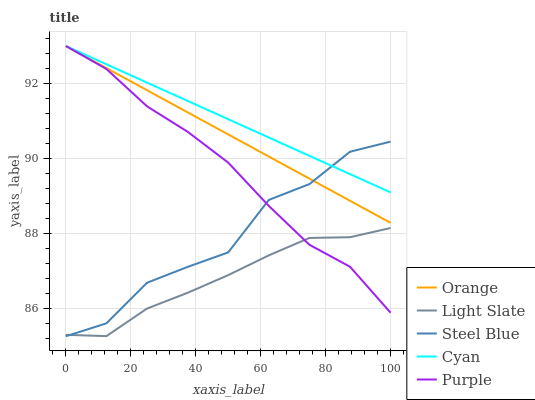Does Light Slate have the minimum area under the curve?
Answer yes or no. Yes. Does Cyan have the maximum area under the curve?
Answer yes or no. Yes. Does Steel Blue have the minimum area under the curve?
Answer yes or no. No. Does Steel Blue have the maximum area under the curve?
Answer yes or no. No. Is Orange the smoothest?
Answer yes or no. Yes. Is Steel Blue the roughest?
Answer yes or no. Yes. Is Light Slate the smoothest?
Answer yes or no. No. Is Light Slate the roughest?
Answer yes or no. No. Does Steel Blue have the lowest value?
Answer yes or no. Yes. Does Light Slate have the lowest value?
Answer yes or no. No. Does Cyan have the highest value?
Answer yes or no. Yes. Does Steel Blue have the highest value?
Answer yes or no. No. Is Light Slate less than Orange?
Answer yes or no. Yes. Is Orange greater than Light Slate?
Answer yes or no. Yes. Does Cyan intersect Orange?
Answer yes or no. Yes. Is Cyan less than Orange?
Answer yes or no. No. Is Cyan greater than Orange?
Answer yes or no. No. Does Light Slate intersect Orange?
Answer yes or no. No. 